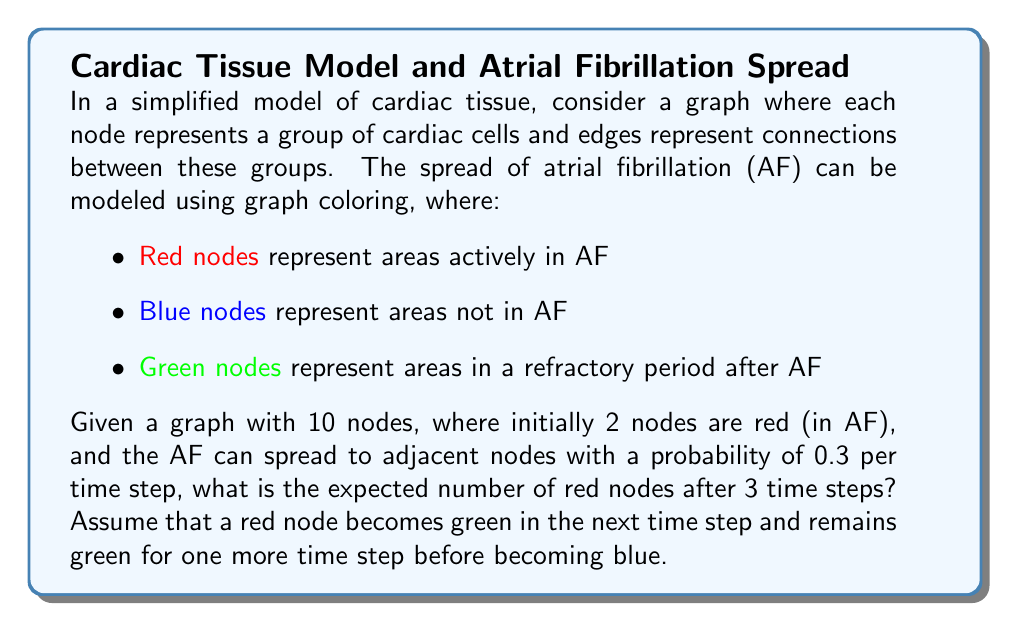Can you answer this question? To solve this problem, we need to consider the progression of the graph coloring over time:

1. Initial state (t=0):
   - 2 red nodes
   - 8 blue nodes
   - 0 green nodes

2. For each time step:
   a) Red nodes become green
   b) Green nodes from the previous step become blue
   c) Blue nodes adjacent to red nodes have a 0.3 probability of becoming red

Let's calculate the expected number of red nodes for each time step:

Time step 1 (t=1):
- The 2 initial red nodes become green
- Expected new red nodes = 8 (blue nodes) * 0.3 (probability) * 2 (adjacent to red) = 4.8
- Expected red nodes at t=1: 4.8

Time step 2 (t=2):
- 4.8 red nodes from t=1 become green
- 2 green nodes from t=0 become blue
- Expected new red nodes = (8 - 4.8 + 2) * 0.3 * 4.8 / 9 = 0.8
- Expected red nodes at t=2: 0.8

Time step 3 (t=3):
- 0.8 red nodes from t=2 become green
- 4.8 green nodes from t=1 become blue
- Expected new red nodes = (8 - 0.8 + 4.8) * 0.3 * 0.8 / 9 = 0.32

The expected number of red nodes after 3 time steps is 0.32.
Answer: 0.32 red nodes 